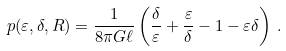<formula> <loc_0><loc_0><loc_500><loc_500>p ( \varepsilon , \delta , R ) = \frac { 1 } { 8 \pi G \ell } \left ( \frac { \delta } { \varepsilon } + \frac { \varepsilon } { \delta } - 1 - \varepsilon \delta \right ) \, .</formula> 